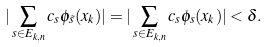Convert formula to latex. <formula><loc_0><loc_0><loc_500><loc_500>| \sum _ { s \in E _ { k , n } } c _ { s } \phi _ { \tilde { s } } ( x _ { k } ) | = | \sum _ { s \in E _ { k , n } } c _ { s } \phi _ { s } ( x _ { k } ) | < \delta .</formula> 